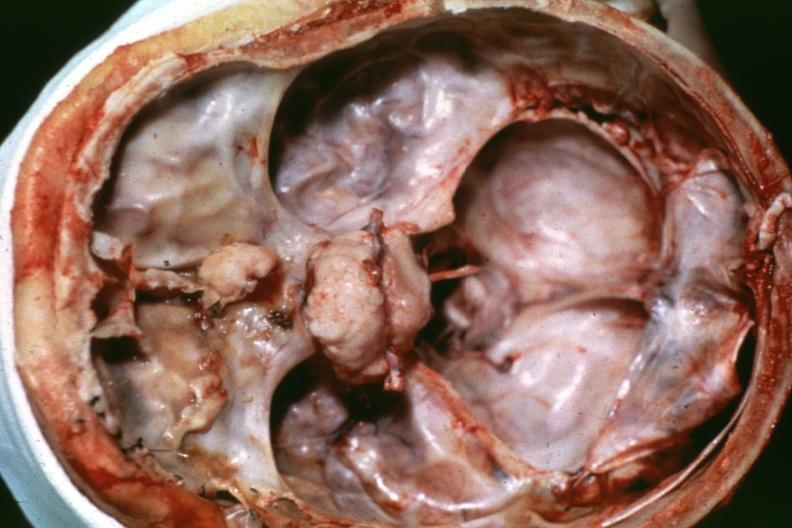what does this image show?
Answer the question using a single word or phrase. Anterior fossa lesion dr garcia tumors b42 